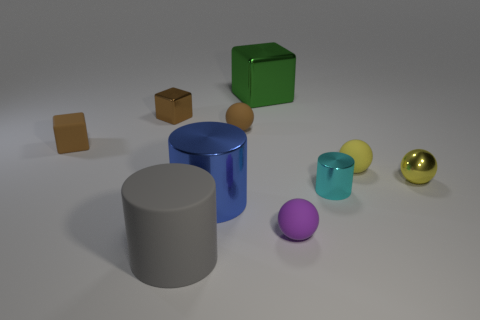There is a ball that is made of the same material as the big green cube; what is its color?
Your answer should be very brief. Yellow. Is the number of tiny cylinders in front of the large metallic cylinder the same as the number of metallic things?
Your response must be concise. No. Do the brown rubber object behind the matte cube and the big metal cylinder have the same size?
Offer a very short reply. No. The metal cylinder that is the same size as the gray rubber object is what color?
Your response must be concise. Blue. Is there a big rubber thing on the left side of the tiny brown block in front of the small brown matte thing right of the big rubber cylinder?
Provide a succinct answer. No. What material is the thing in front of the small purple thing?
Your answer should be very brief. Rubber. There is a big blue object; does it have the same shape as the big thing that is in front of the big blue shiny cylinder?
Provide a succinct answer. Yes. Are there an equal number of small brown objects in front of the green object and metal objects left of the large blue metal cylinder?
Make the answer very short. No. What number of other things are made of the same material as the cyan cylinder?
Offer a terse response. 4. How many rubber things are either tiny cubes or big brown spheres?
Provide a succinct answer. 1. 